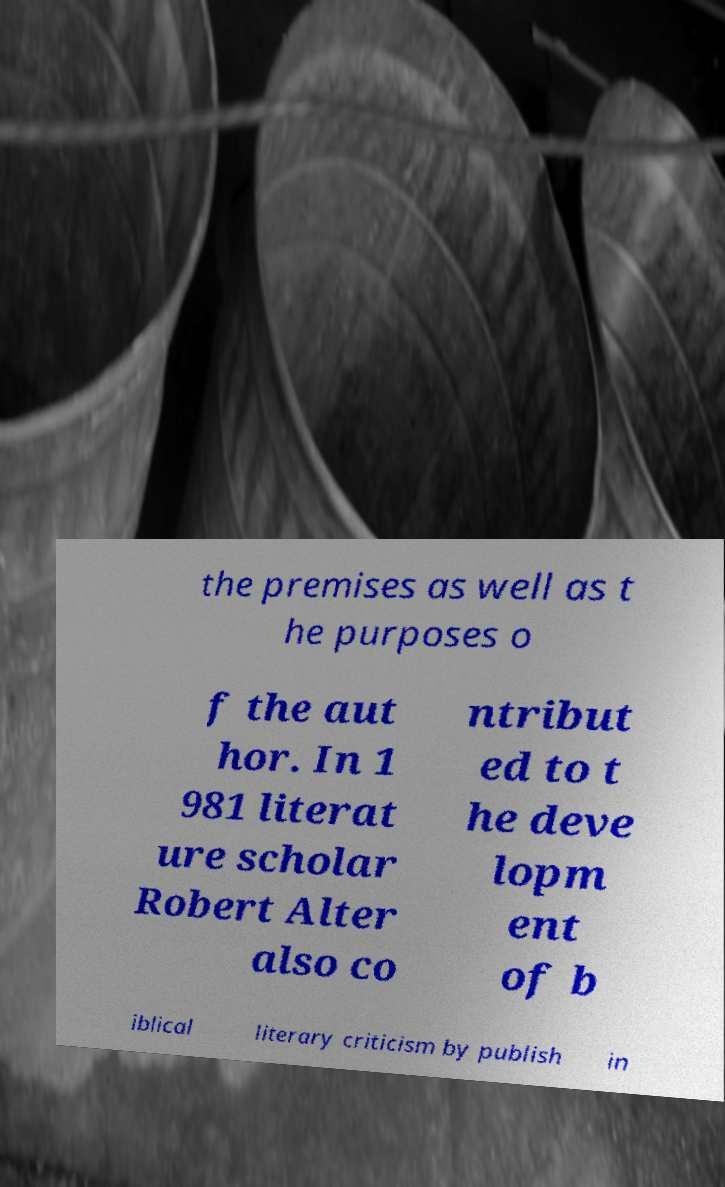What messages or text are displayed in this image? I need them in a readable, typed format. the premises as well as t he purposes o f the aut hor. In 1 981 literat ure scholar Robert Alter also co ntribut ed to t he deve lopm ent of b iblical literary criticism by publish in 